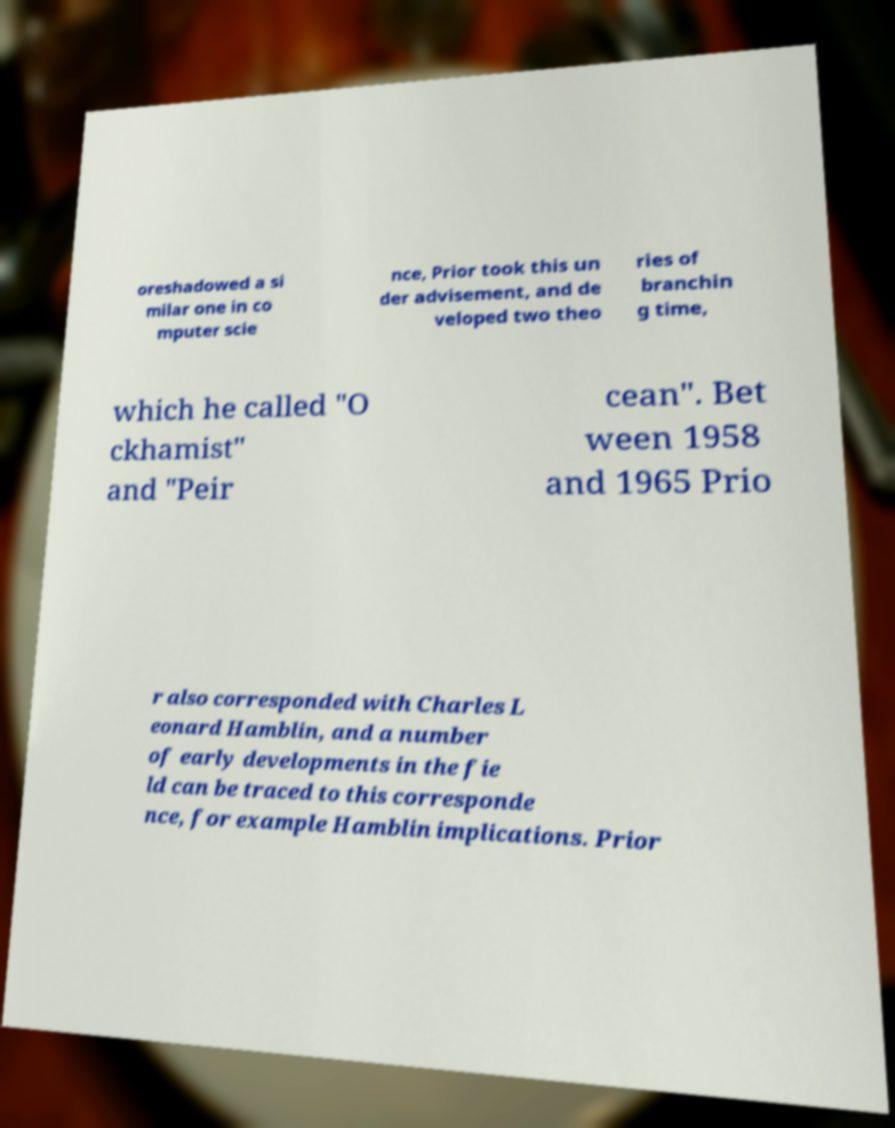There's text embedded in this image that I need extracted. Can you transcribe it verbatim? oreshadowed a si milar one in co mputer scie nce, Prior took this un der advisement, and de veloped two theo ries of branchin g time, which he called "O ckhamist" and "Peir cean". Bet ween 1958 and 1965 Prio r also corresponded with Charles L eonard Hamblin, and a number of early developments in the fie ld can be traced to this corresponde nce, for example Hamblin implications. Prior 